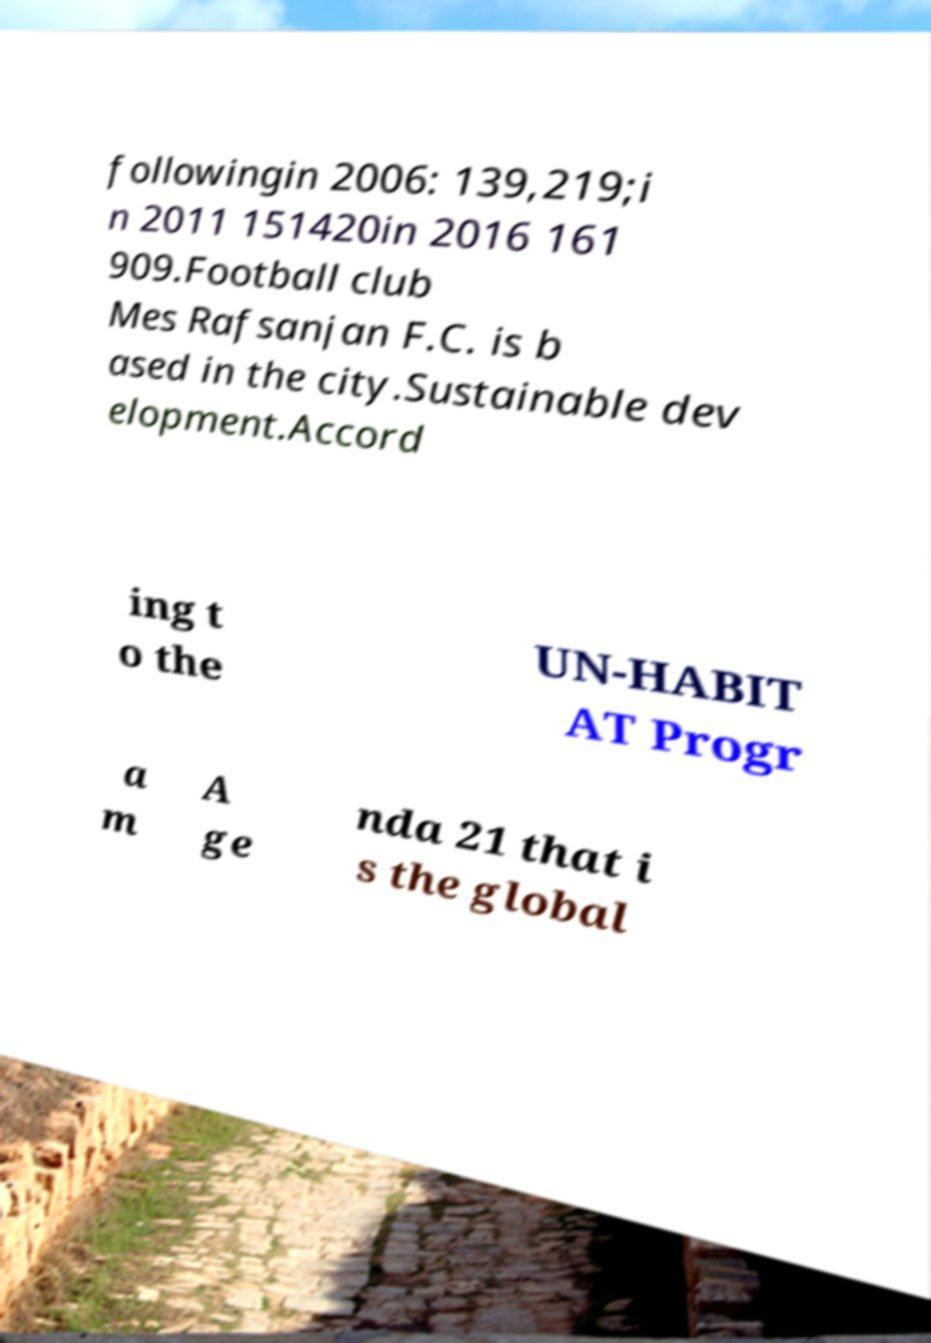Can you accurately transcribe the text from the provided image for me? followingin 2006: 139,219;i n 2011 151420in 2016 161 909.Football club Mes Rafsanjan F.C. is b ased in the city.Sustainable dev elopment.Accord ing t o the UN-HABIT AT Progr a m A ge nda 21 that i s the global 